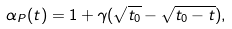Convert formula to latex. <formula><loc_0><loc_0><loc_500><loc_500>\alpha _ { P } ( t ) = 1 + \gamma ( \sqrt { t _ { 0 } } - \sqrt { t _ { 0 } - t } ) ,</formula> 